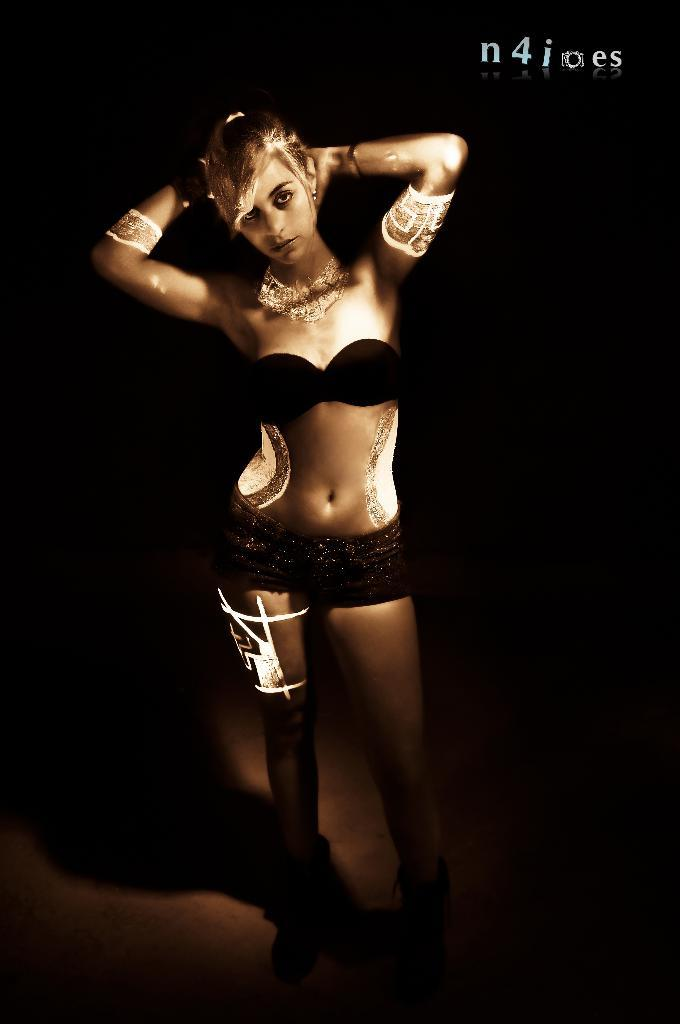What is the main subject of the image? There is a person standing and posing in the image. What can be observed in relation to the person in the image? There is a shadow in the image. What color is the background of the image? The background of the image is black. Is there any additional text or marking in the image? Yes, there is a watermark at the top of the image. What type of song is being sung by the toad in the image? There is no toad or song present in the image; it features a person standing and posing against a black background with a shadow and a watermark. 